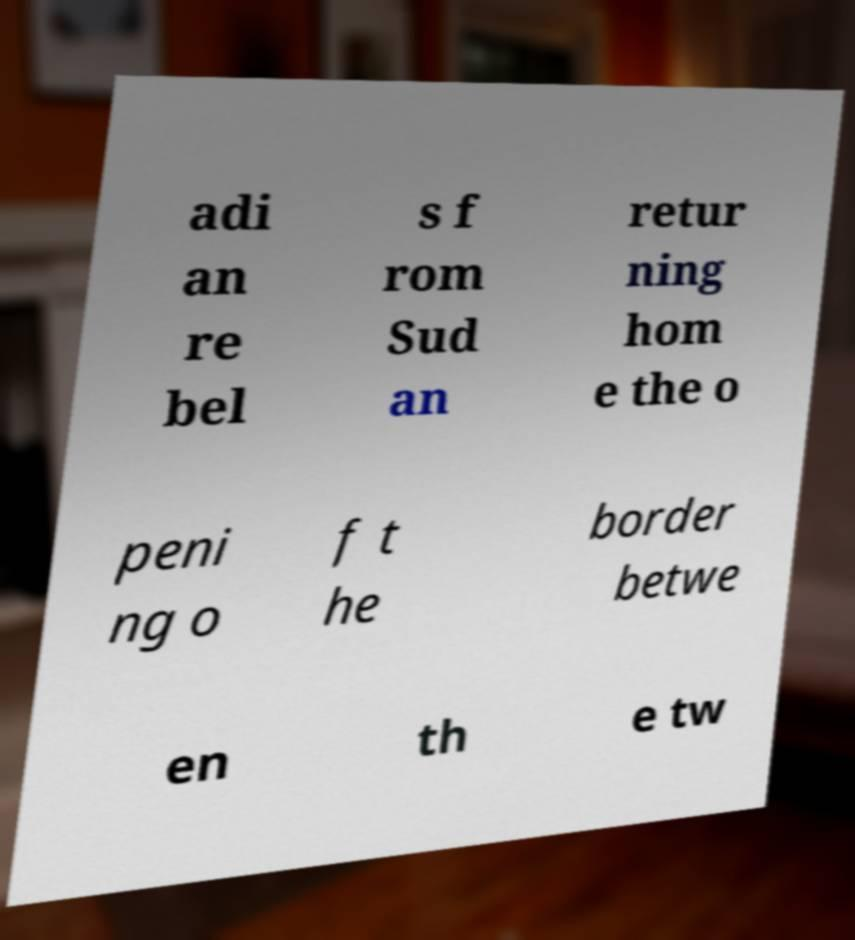Could you extract and type out the text from this image? adi an re bel s f rom Sud an retur ning hom e the o peni ng o f t he border betwe en th e tw 